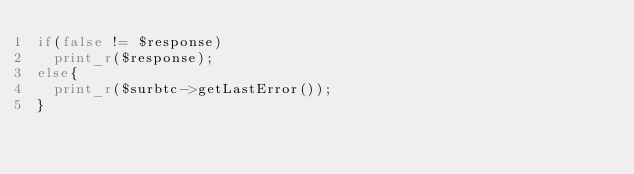Convert code to text. <code><loc_0><loc_0><loc_500><loc_500><_PHP_>if(false != $response)
  print_r($response);
else{
  print_r($surbtc->getLastError());
}

</code> 